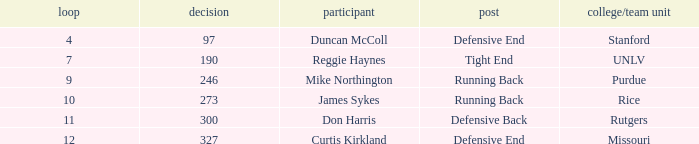What is the total number of rounds that had draft pick 97, duncan mccoll? 0.0. 